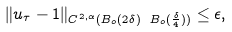Convert formula to latex. <formula><loc_0><loc_0><loc_500><loc_500>\| u _ { \tau } - 1 \| _ { C ^ { 2 , \alpha } ( B _ { o } ( 2 \delta ) \ B _ { o } ( \frac { \delta } { 4 } ) ) } \leq \epsilon ,</formula> 